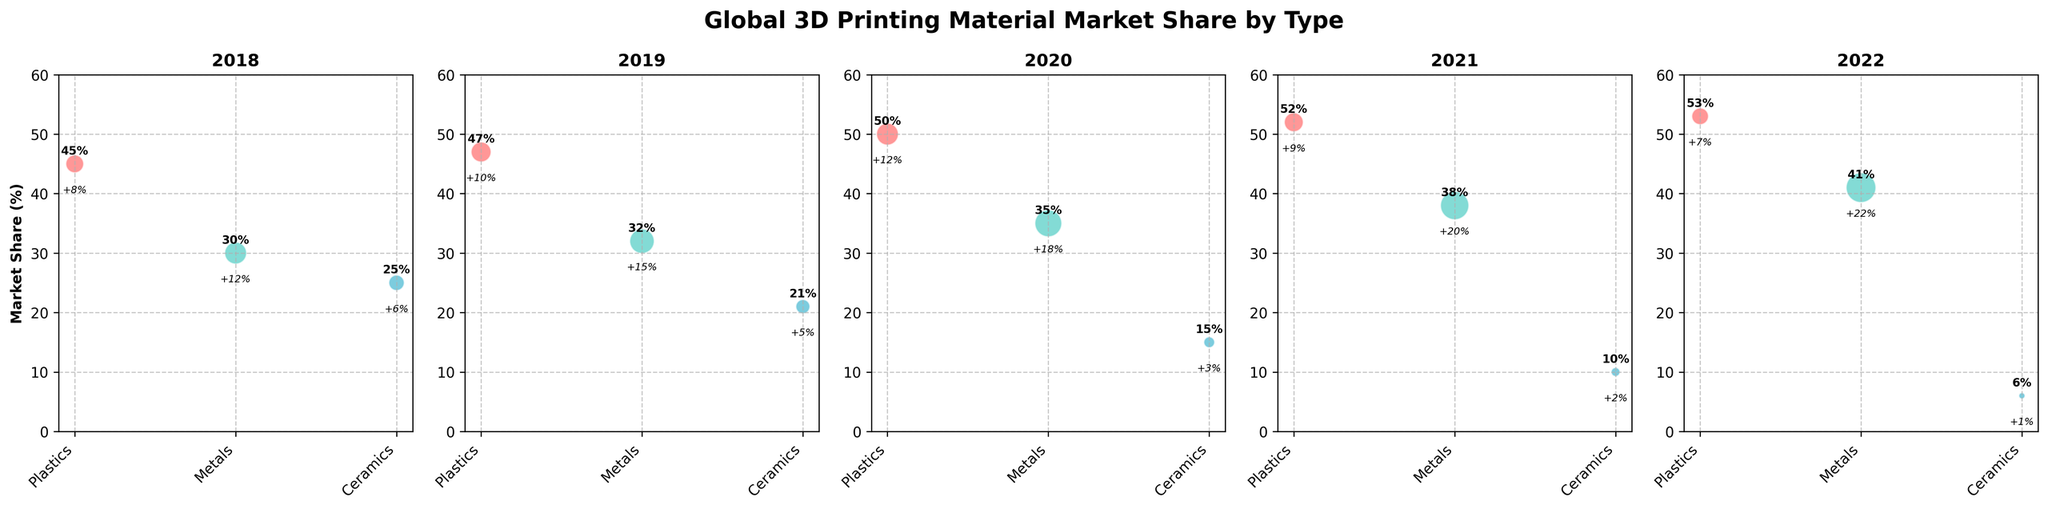What is the title of the figure? The title of the figure is bold and distinctly located at the top.
Answer: Global 3D Printing Material Market Share by Type What is the market share of metals in 2022? Refer to the bubble for metals in the subplot labeled "2022" and read the percentage annotated inside or near the bubble.
Answer: 41% Which year had the highest growth rate for plastics? Compare the growth rates of plastics bubbles across all subplots. The one with the largest growth rate value indicates the highest year.
Answer: 2020 How does the market share of ceramics change from 2018 to 2022? Look at the trend of the percentage annotations for ceramics bubbles over the years from 2018 to 2022.
Answer: Decreases from 25% to 6% What is the average market share of metals from 2018 to 2022? Calculate the mean percentage of the metals' market share for the years 2018, 2019, 2020, 2021, and 2022. (30 + 32 + 35 + 38 + 41) / 5 = 35.2
Answer: 35.2% Which material type has the lowest growth rate in 2021? Check the annotated growth rate percentages for each material type in the subplot for 2021 and identify the smallest value.
Answer: Ceramics Compare the market share of plastics in 2018 vs. 2019. Which year had a higher share? Look at the percentage annotations for plastics in the subplots for 2018 and 2019 and compare them.
Answer: 2019 What is the overall trend in market share for metals from 2018 to 2022? Observe the annotated market share percentages for metals in each subplot from 2018 to 2022 and describe the trend.
Answer: Increasing What is the sum of the market shares for all materials in 2020? Add the market share percentages for plastics, metals, and ceramics in 2020 (50% + 35% + 15%).
Answer: 100% Which year shows ceramics with a growth rate of 2%? Look for the subplot where the ceramics bubble shows an annotated growth rate of '2%'.
Answer: 2021 